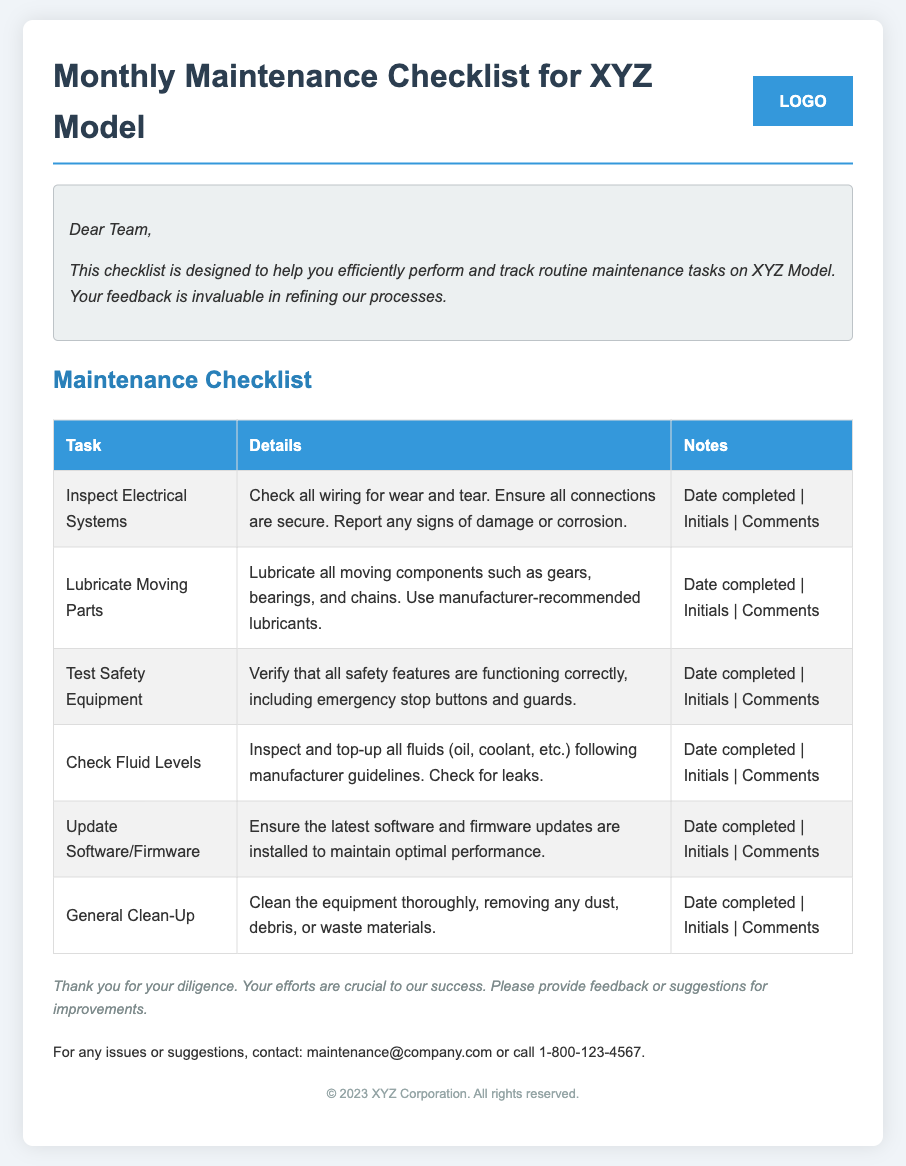What is the title of the document? The title is prominently displayed at the top of the document and indicates the contents of the checklist.
Answer: Monthly Maintenance Checklist for XYZ Model How many tasks are listed in the Maintenance Checklist? There are multiple tasks listed in the checklist table under the "Task" column.
Answer: Six What is the first task to be performed? The first task is detailed in the first row of the checklist table.
Answer: Inspect Electrical Systems What should be checked according to the "Check Fluid Levels" task? The details provided under "Check Fluid Levels" outline specific items to pay attention to during the maintenance.
Answer: Fluids (oil, coolant, etc.) What kind of note does the manager include at the end of the document? The document contains a note expressing gratitude and encouraging feedback from the technicians.
Answer: Thank you for your diligence. Your efforts are crucial to our success. Please provide feedback or suggestions for improvements What is the contact email for suggestions or issues? The contact information section at the end of the document provides an email for communication.
Answer: maintenance@company.com 